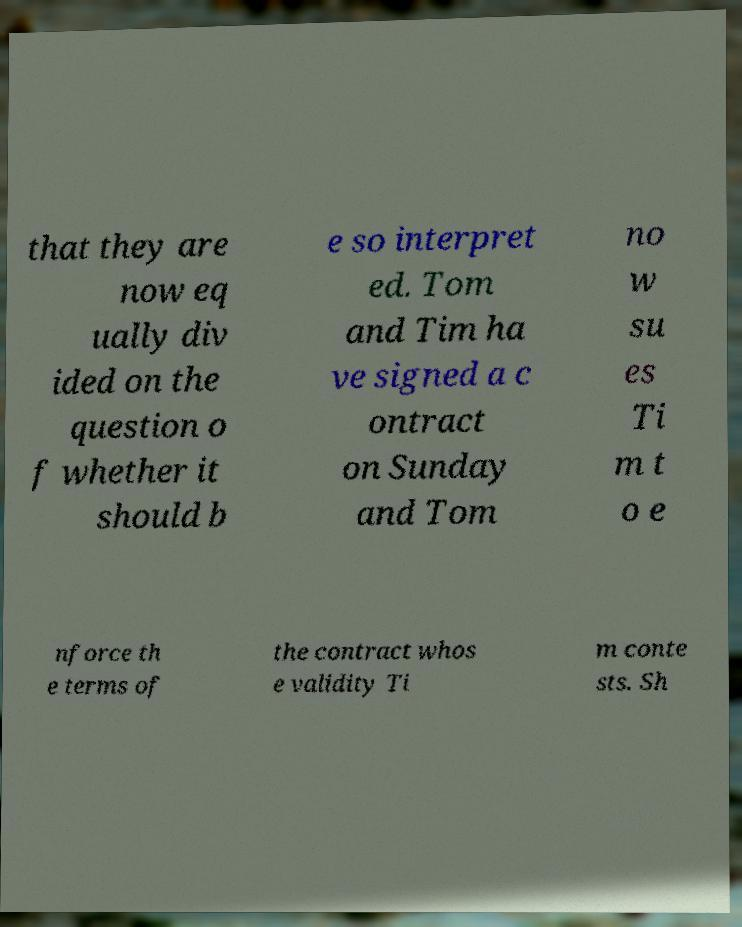Can you read and provide the text displayed in the image?This photo seems to have some interesting text. Can you extract and type it out for me? that they are now eq ually div ided on the question o f whether it should b e so interpret ed. Tom and Tim ha ve signed a c ontract on Sunday and Tom no w su es Ti m t o e nforce th e terms of the contract whos e validity Ti m conte sts. Sh 